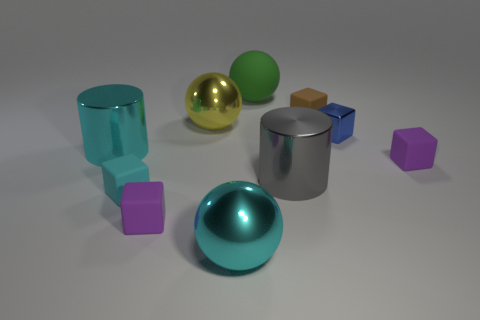What material is the tiny cube that is to the right of the blue thing?
Your response must be concise. Rubber. What number of purple objects are the same shape as the gray thing?
Keep it short and to the point. 0. What is the material of the small thing to the left of the small purple block in front of the small cyan rubber cube?
Provide a short and direct response. Rubber. Are there any large cyan spheres made of the same material as the large green sphere?
Provide a short and direct response. No. What is the shape of the tiny cyan matte thing?
Give a very brief answer. Cube. How many brown shiny objects are there?
Your response must be concise. 0. There is a small cube on the right side of the tiny blue thing that is behind the tiny cyan matte thing; what is its color?
Your answer should be very brief. Purple. There is a metallic block that is the same size as the cyan rubber cube; what color is it?
Offer a terse response. Blue. Are any tiny purple rubber balls visible?
Provide a short and direct response. No. There is a cyan metal thing behind the cyan metal ball; what shape is it?
Your response must be concise. Cylinder. 